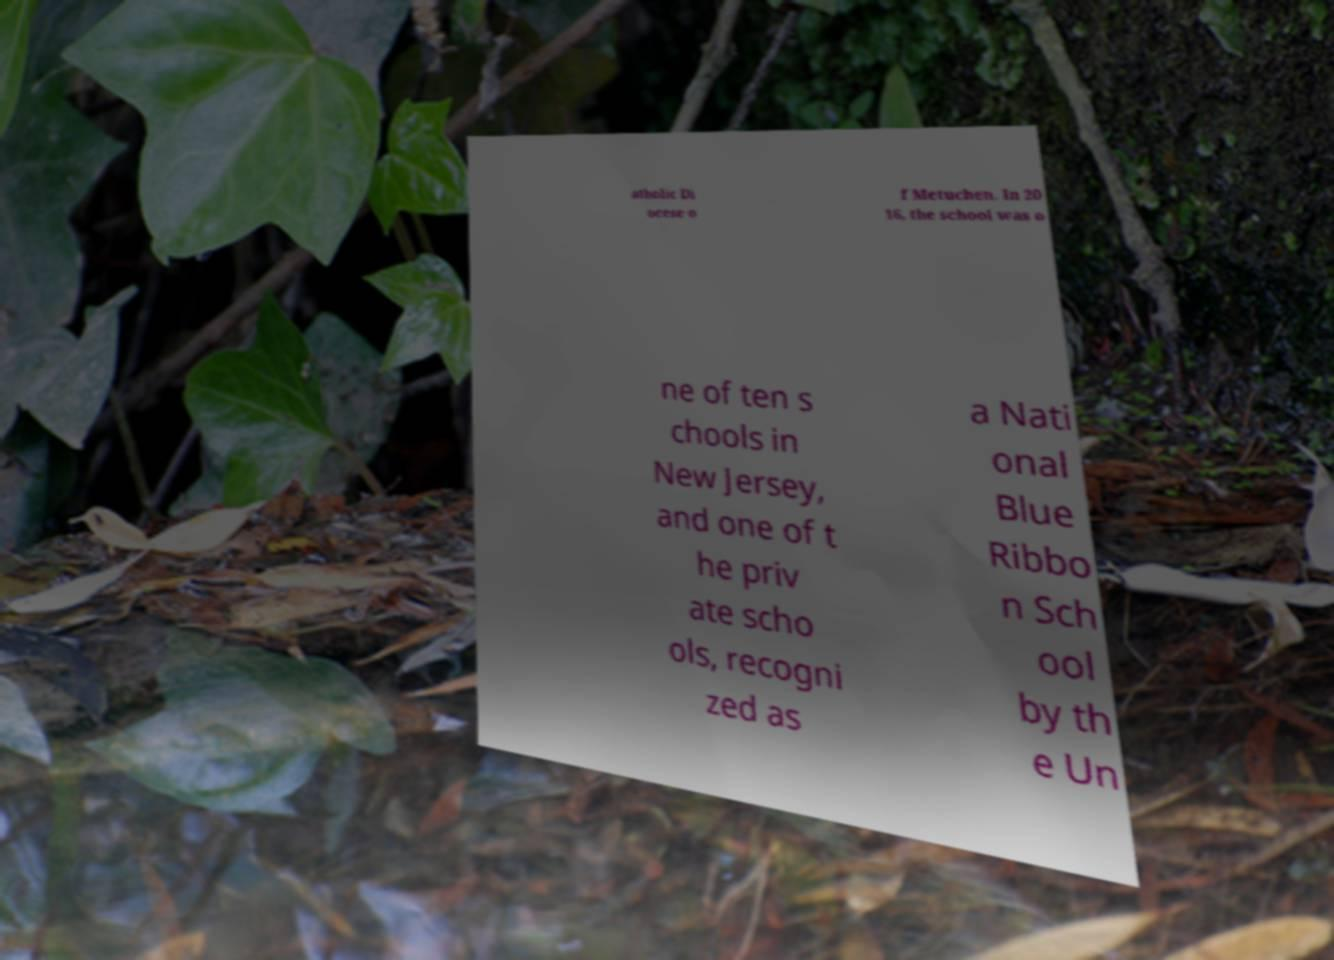There's text embedded in this image that I need extracted. Can you transcribe it verbatim? atholic Di ocese o f Metuchen. In 20 16, the school was o ne of ten s chools in New Jersey, and one of t he priv ate scho ols, recogni zed as a Nati onal Blue Ribbo n Sch ool by th e Un 